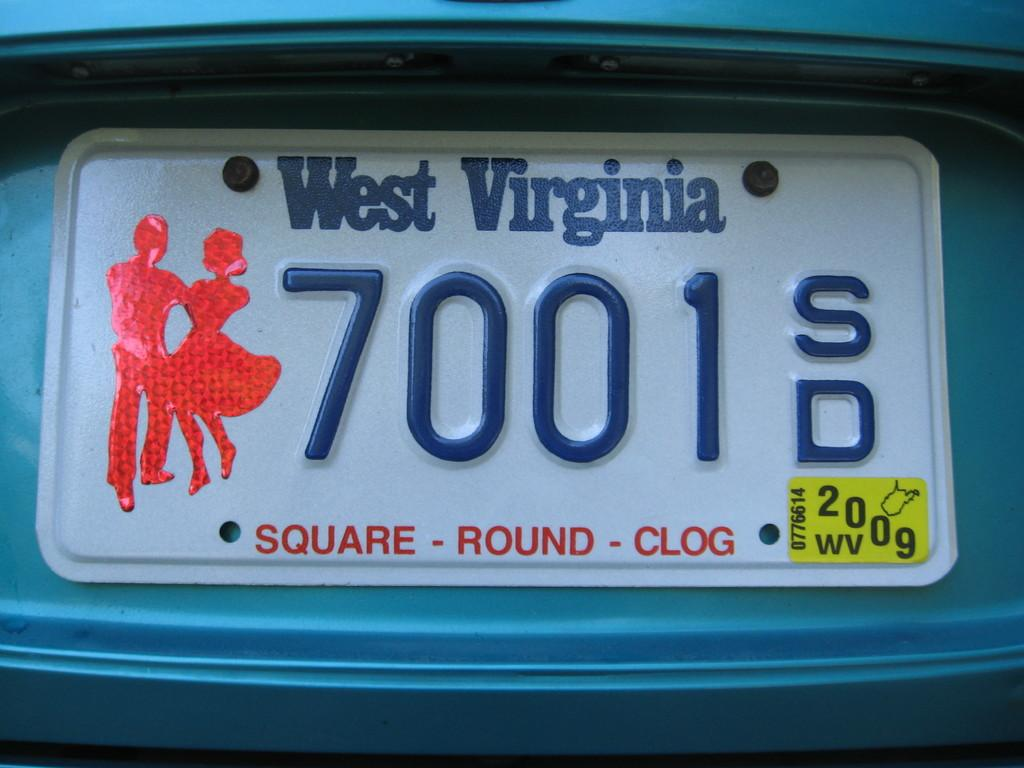<image>
Offer a succinct explanation of the picture presented. A West Virginia license plate says "SQUARE ROUND CLOG." 